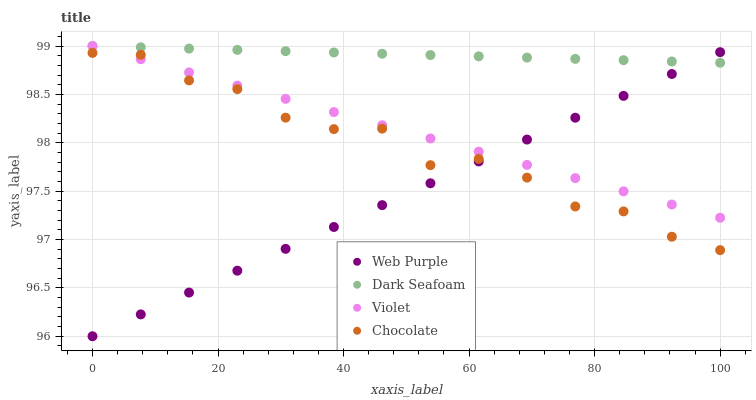Does Web Purple have the minimum area under the curve?
Answer yes or no. Yes. Does Dark Seafoam have the maximum area under the curve?
Answer yes or no. Yes. Does Chocolate have the minimum area under the curve?
Answer yes or no. No. Does Chocolate have the maximum area under the curve?
Answer yes or no. No. Is Violet the smoothest?
Answer yes or no. Yes. Is Chocolate the roughest?
Answer yes or no. Yes. Is Dark Seafoam the smoothest?
Answer yes or no. No. Is Dark Seafoam the roughest?
Answer yes or no. No. Does Web Purple have the lowest value?
Answer yes or no. Yes. Does Chocolate have the lowest value?
Answer yes or no. No. Does Violet have the highest value?
Answer yes or no. Yes. Does Chocolate have the highest value?
Answer yes or no. No. Is Chocolate less than Dark Seafoam?
Answer yes or no. Yes. Is Dark Seafoam greater than Chocolate?
Answer yes or no. Yes. Does Web Purple intersect Dark Seafoam?
Answer yes or no. Yes. Is Web Purple less than Dark Seafoam?
Answer yes or no. No. Is Web Purple greater than Dark Seafoam?
Answer yes or no. No. Does Chocolate intersect Dark Seafoam?
Answer yes or no. No. 